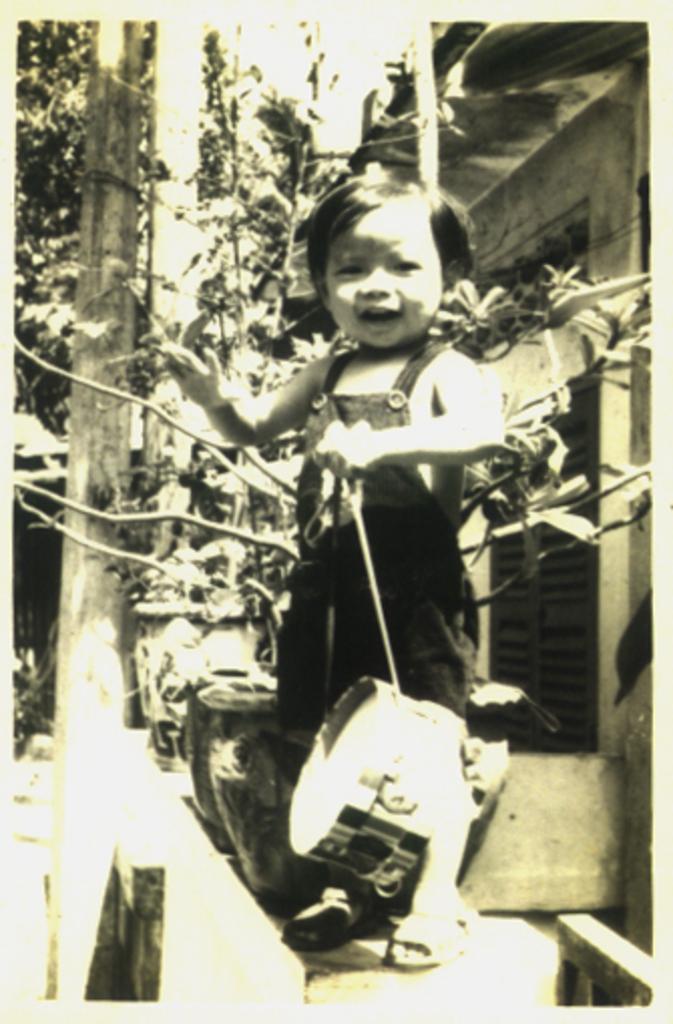How would you summarize this image in a sentence or two? In the foreground of this black and white image, there is a kid holding an object. Behind the kid, there are flower vases, wall, pole and a window. 